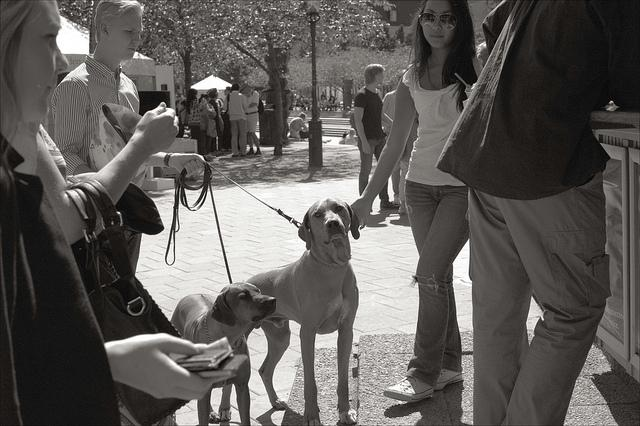How many dogs are held on the leashes? Please explain your reasoning. two. There are two dogs being held on leashes with the group of people. 